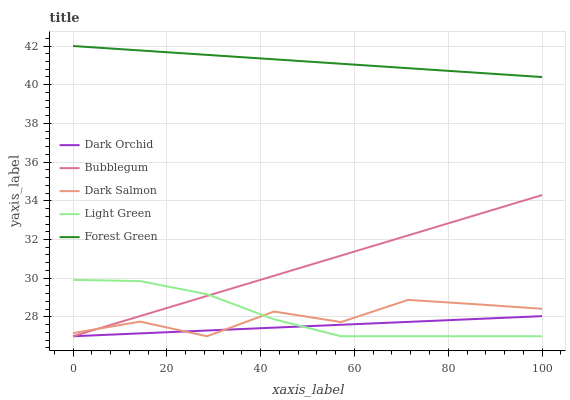Does Light Green have the minimum area under the curve?
Answer yes or no. No. Does Light Green have the maximum area under the curve?
Answer yes or no. No. Is Light Green the smoothest?
Answer yes or no. No. Is Light Green the roughest?
Answer yes or no. No. Does Light Green have the highest value?
Answer yes or no. No. Is Dark Orchid less than Forest Green?
Answer yes or no. Yes. Is Forest Green greater than Dark Orchid?
Answer yes or no. Yes. Does Dark Orchid intersect Forest Green?
Answer yes or no. No. 